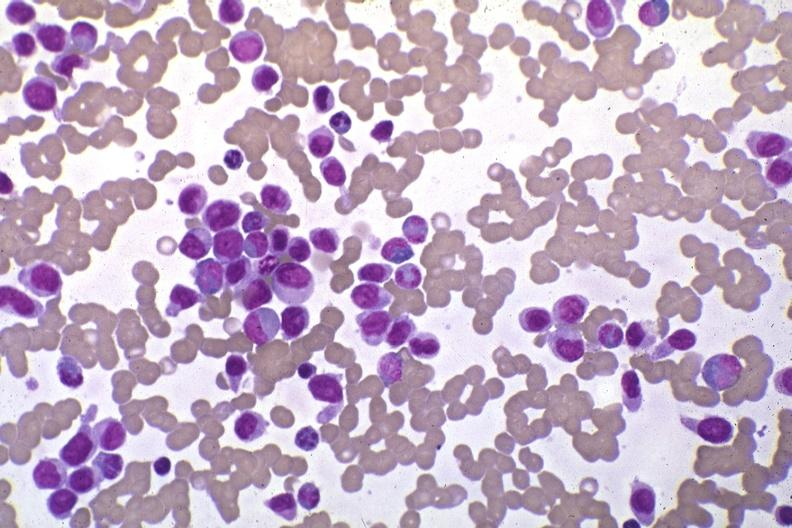what is present?
Answer the question using a single word or phrase. Acute monocytic leukemia 